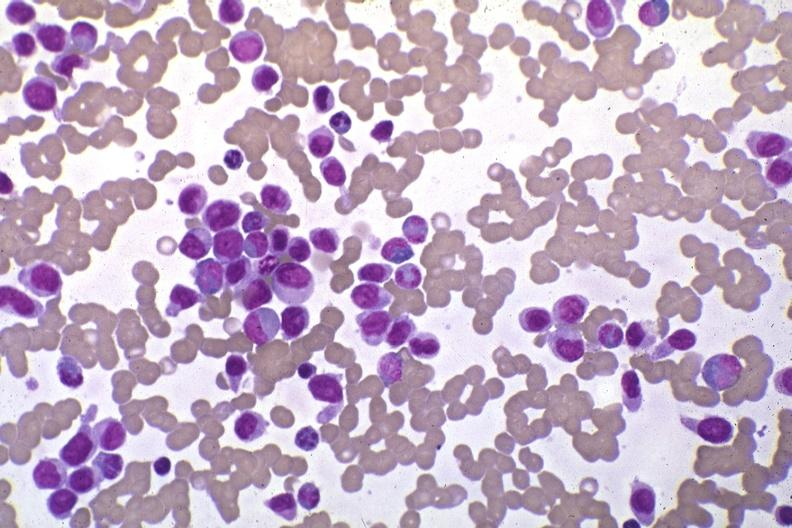what is present?
Answer the question using a single word or phrase. Acute monocytic leukemia 